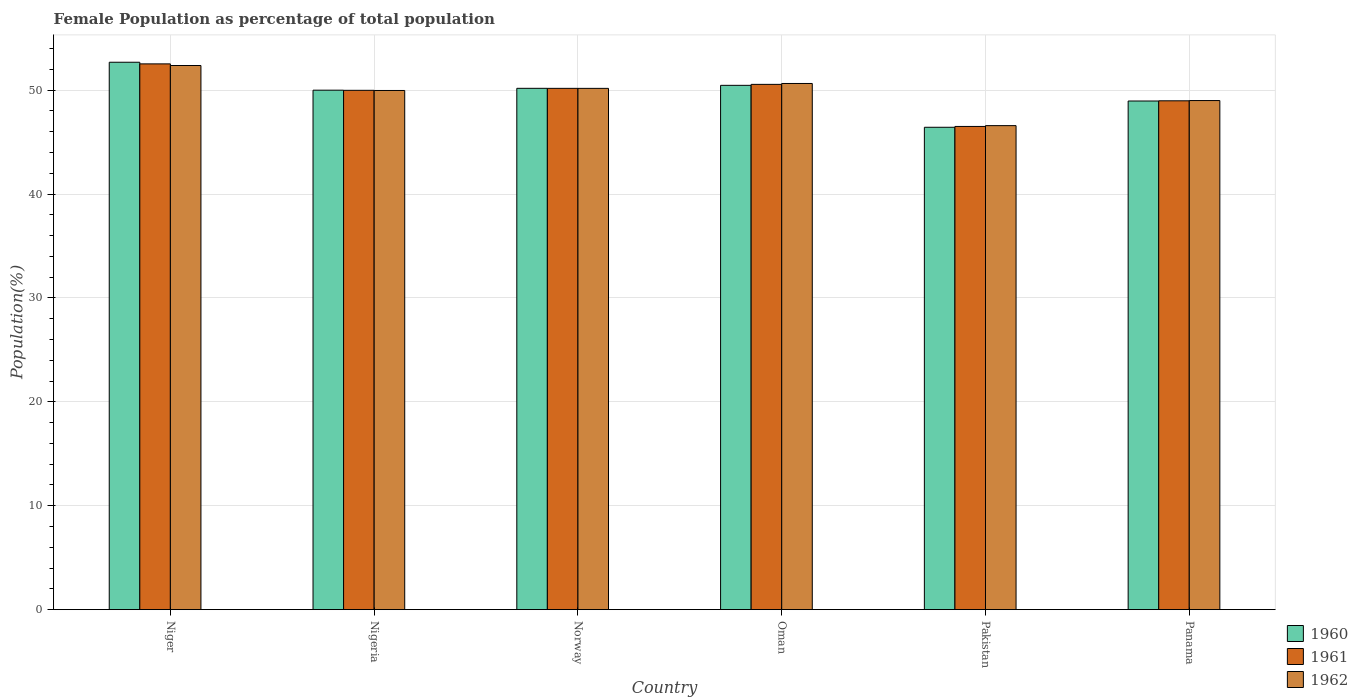Are the number of bars per tick equal to the number of legend labels?
Provide a short and direct response. Yes. Are the number of bars on each tick of the X-axis equal?
Your response must be concise. Yes. How many bars are there on the 5th tick from the left?
Ensure brevity in your answer.  3. What is the label of the 2nd group of bars from the left?
Keep it short and to the point. Nigeria. What is the female population in in 1962 in Oman?
Provide a short and direct response. 50.65. Across all countries, what is the maximum female population in in 1961?
Keep it short and to the point. 52.54. Across all countries, what is the minimum female population in in 1961?
Ensure brevity in your answer.  46.51. In which country was the female population in in 1962 maximum?
Offer a very short reply. Niger. What is the total female population in in 1962 in the graph?
Your answer should be compact. 298.77. What is the difference between the female population in in 1962 in Oman and that in Pakistan?
Your response must be concise. 4.06. What is the difference between the female population in in 1962 in Norway and the female population in in 1960 in Nigeria?
Your answer should be compact. 0.17. What is the average female population in in 1962 per country?
Offer a terse response. 49.8. What is the difference between the female population in of/in 1960 and female population in of/in 1962 in Oman?
Make the answer very short. -0.18. What is the ratio of the female population in in 1962 in Niger to that in Norway?
Your response must be concise. 1.04. What is the difference between the highest and the second highest female population in in 1962?
Provide a short and direct response. -1.73. What is the difference between the highest and the lowest female population in in 1960?
Give a very brief answer. 6.26. Is it the case that in every country, the sum of the female population in in 1962 and female population in in 1961 is greater than the female population in in 1960?
Make the answer very short. Yes. How many bars are there?
Give a very brief answer. 18. What is the difference between two consecutive major ticks on the Y-axis?
Offer a terse response. 10. Does the graph contain any zero values?
Provide a succinct answer. No. Does the graph contain grids?
Offer a terse response. Yes. Where does the legend appear in the graph?
Provide a short and direct response. Bottom right. What is the title of the graph?
Ensure brevity in your answer.  Female Population as percentage of total population. Does "1998" appear as one of the legend labels in the graph?
Offer a terse response. No. What is the label or title of the X-axis?
Offer a terse response. Country. What is the label or title of the Y-axis?
Your answer should be very brief. Population(%). What is the Population(%) of 1960 in Niger?
Keep it short and to the point. 52.69. What is the Population(%) in 1961 in Niger?
Give a very brief answer. 52.54. What is the Population(%) in 1962 in Niger?
Your response must be concise. 52.38. What is the Population(%) in 1960 in Nigeria?
Provide a succinct answer. 50. What is the Population(%) in 1961 in Nigeria?
Ensure brevity in your answer.  49.99. What is the Population(%) in 1962 in Nigeria?
Make the answer very short. 49.98. What is the Population(%) of 1960 in Norway?
Offer a terse response. 50.18. What is the Population(%) of 1961 in Norway?
Offer a very short reply. 50.18. What is the Population(%) in 1962 in Norway?
Give a very brief answer. 50.18. What is the Population(%) of 1960 in Oman?
Your response must be concise. 50.47. What is the Population(%) of 1961 in Oman?
Provide a succinct answer. 50.56. What is the Population(%) in 1962 in Oman?
Provide a short and direct response. 50.65. What is the Population(%) in 1960 in Pakistan?
Your answer should be very brief. 46.43. What is the Population(%) of 1961 in Pakistan?
Offer a very short reply. 46.51. What is the Population(%) of 1962 in Pakistan?
Your response must be concise. 46.59. What is the Population(%) in 1960 in Panama?
Your answer should be compact. 48.96. What is the Population(%) in 1961 in Panama?
Give a very brief answer. 48.98. What is the Population(%) of 1962 in Panama?
Make the answer very short. 49. Across all countries, what is the maximum Population(%) of 1960?
Provide a succinct answer. 52.69. Across all countries, what is the maximum Population(%) in 1961?
Ensure brevity in your answer.  52.54. Across all countries, what is the maximum Population(%) in 1962?
Give a very brief answer. 52.38. Across all countries, what is the minimum Population(%) in 1960?
Provide a short and direct response. 46.43. Across all countries, what is the minimum Population(%) in 1961?
Make the answer very short. 46.51. Across all countries, what is the minimum Population(%) in 1962?
Offer a terse response. 46.59. What is the total Population(%) in 1960 in the graph?
Your answer should be very brief. 298.74. What is the total Population(%) of 1961 in the graph?
Your answer should be very brief. 298.76. What is the total Population(%) in 1962 in the graph?
Ensure brevity in your answer.  298.77. What is the difference between the Population(%) in 1960 in Niger and that in Nigeria?
Make the answer very short. 2.69. What is the difference between the Population(%) of 1961 in Niger and that in Nigeria?
Provide a succinct answer. 2.55. What is the difference between the Population(%) of 1962 in Niger and that in Nigeria?
Your response must be concise. 2.4. What is the difference between the Population(%) in 1960 in Niger and that in Norway?
Ensure brevity in your answer.  2.51. What is the difference between the Population(%) in 1961 in Niger and that in Norway?
Make the answer very short. 2.36. What is the difference between the Population(%) of 1962 in Niger and that in Norway?
Give a very brief answer. 2.2. What is the difference between the Population(%) in 1960 in Niger and that in Oman?
Your response must be concise. 2.22. What is the difference between the Population(%) in 1961 in Niger and that in Oman?
Ensure brevity in your answer.  1.97. What is the difference between the Population(%) of 1962 in Niger and that in Oman?
Your response must be concise. 1.73. What is the difference between the Population(%) in 1960 in Niger and that in Pakistan?
Offer a terse response. 6.26. What is the difference between the Population(%) in 1961 in Niger and that in Pakistan?
Your answer should be very brief. 6.02. What is the difference between the Population(%) of 1962 in Niger and that in Pakistan?
Give a very brief answer. 5.79. What is the difference between the Population(%) of 1960 in Niger and that in Panama?
Offer a very short reply. 3.73. What is the difference between the Population(%) of 1961 in Niger and that in Panama?
Offer a terse response. 3.55. What is the difference between the Population(%) of 1962 in Niger and that in Panama?
Keep it short and to the point. 3.37. What is the difference between the Population(%) of 1960 in Nigeria and that in Norway?
Your answer should be compact. -0.18. What is the difference between the Population(%) in 1961 in Nigeria and that in Norway?
Your response must be concise. -0.19. What is the difference between the Population(%) of 1962 in Nigeria and that in Norway?
Provide a short and direct response. -0.2. What is the difference between the Population(%) of 1960 in Nigeria and that in Oman?
Provide a succinct answer. -0.47. What is the difference between the Population(%) of 1961 in Nigeria and that in Oman?
Provide a succinct answer. -0.57. What is the difference between the Population(%) in 1962 in Nigeria and that in Oman?
Make the answer very short. -0.67. What is the difference between the Population(%) of 1960 in Nigeria and that in Pakistan?
Your answer should be very brief. 3.57. What is the difference between the Population(%) in 1961 in Nigeria and that in Pakistan?
Provide a succinct answer. 3.48. What is the difference between the Population(%) in 1962 in Nigeria and that in Pakistan?
Provide a succinct answer. 3.38. What is the difference between the Population(%) of 1960 in Nigeria and that in Panama?
Your answer should be compact. 1.04. What is the difference between the Population(%) in 1961 in Nigeria and that in Panama?
Ensure brevity in your answer.  1.01. What is the difference between the Population(%) of 1962 in Nigeria and that in Panama?
Your answer should be compact. 0.97. What is the difference between the Population(%) of 1960 in Norway and that in Oman?
Provide a short and direct response. -0.29. What is the difference between the Population(%) of 1961 in Norway and that in Oman?
Your answer should be very brief. -0.38. What is the difference between the Population(%) of 1962 in Norway and that in Oman?
Your answer should be very brief. -0.47. What is the difference between the Population(%) in 1960 in Norway and that in Pakistan?
Your answer should be very brief. 3.75. What is the difference between the Population(%) in 1961 in Norway and that in Pakistan?
Your response must be concise. 3.67. What is the difference between the Population(%) of 1962 in Norway and that in Pakistan?
Offer a very short reply. 3.59. What is the difference between the Population(%) in 1960 in Norway and that in Panama?
Make the answer very short. 1.22. What is the difference between the Population(%) of 1961 in Norway and that in Panama?
Provide a succinct answer. 1.2. What is the difference between the Population(%) of 1962 in Norway and that in Panama?
Your answer should be very brief. 1.17. What is the difference between the Population(%) in 1960 in Oman and that in Pakistan?
Offer a very short reply. 4.04. What is the difference between the Population(%) of 1961 in Oman and that in Pakistan?
Provide a short and direct response. 4.05. What is the difference between the Population(%) in 1962 in Oman and that in Pakistan?
Your answer should be compact. 4.06. What is the difference between the Population(%) of 1960 in Oman and that in Panama?
Your response must be concise. 1.51. What is the difference between the Population(%) in 1961 in Oman and that in Panama?
Your response must be concise. 1.58. What is the difference between the Population(%) in 1962 in Oman and that in Panama?
Your response must be concise. 1.64. What is the difference between the Population(%) in 1960 in Pakistan and that in Panama?
Your answer should be very brief. -2.53. What is the difference between the Population(%) of 1961 in Pakistan and that in Panama?
Offer a very short reply. -2.47. What is the difference between the Population(%) in 1962 in Pakistan and that in Panama?
Offer a very short reply. -2.41. What is the difference between the Population(%) in 1960 in Niger and the Population(%) in 1961 in Nigeria?
Keep it short and to the point. 2.7. What is the difference between the Population(%) in 1960 in Niger and the Population(%) in 1962 in Nigeria?
Provide a succinct answer. 2.72. What is the difference between the Population(%) in 1961 in Niger and the Population(%) in 1962 in Nigeria?
Make the answer very short. 2.56. What is the difference between the Population(%) in 1960 in Niger and the Population(%) in 1961 in Norway?
Keep it short and to the point. 2.51. What is the difference between the Population(%) in 1960 in Niger and the Population(%) in 1962 in Norway?
Keep it short and to the point. 2.52. What is the difference between the Population(%) in 1961 in Niger and the Population(%) in 1962 in Norway?
Your response must be concise. 2.36. What is the difference between the Population(%) in 1960 in Niger and the Population(%) in 1961 in Oman?
Offer a terse response. 2.13. What is the difference between the Population(%) of 1960 in Niger and the Population(%) of 1962 in Oman?
Give a very brief answer. 2.04. What is the difference between the Population(%) of 1961 in Niger and the Population(%) of 1962 in Oman?
Provide a short and direct response. 1.89. What is the difference between the Population(%) of 1960 in Niger and the Population(%) of 1961 in Pakistan?
Provide a succinct answer. 6.18. What is the difference between the Population(%) of 1960 in Niger and the Population(%) of 1962 in Pakistan?
Provide a succinct answer. 6.1. What is the difference between the Population(%) of 1961 in Niger and the Population(%) of 1962 in Pakistan?
Your response must be concise. 5.95. What is the difference between the Population(%) of 1960 in Niger and the Population(%) of 1961 in Panama?
Provide a short and direct response. 3.71. What is the difference between the Population(%) in 1960 in Niger and the Population(%) in 1962 in Panama?
Ensure brevity in your answer.  3.69. What is the difference between the Population(%) of 1961 in Niger and the Population(%) of 1962 in Panama?
Your answer should be very brief. 3.53. What is the difference between the Population(%) in 1960 in Nigeria and the Population(%) in 1961 in Norway?
Provide a succinct answer. -0.18. What is the difference between the Population(%) in 1960 in Nigeria and the Population(%) in 1962 in Norway?
Your response must be concise. -0.17. What is the difference between the Population(%) in 1961 in Nigeria and the Population(%) in 1962 in Norway?
Provide a short and direct response. -0.19. What is the difference between the Population(%) of 1960 in Nigeria and the Population(%) of 1961 in Oman?
Give a very brief answer. -0.56. What is the difference between the Population(%) in 1960 in Nigeria and the Population(%) in 1962 in Oman?
Offer a very short reply. -0.64. What is the difference between the Population(%) of 1961 in Nigeria and the Population(%) of 1962 in Oman?
Provide a succinct answer. -0.66. What is the difference between the Population(%) of 1960 in Nigeria and the Population(%) of 1961 in Pakistan?
Your answer should be compact. 3.49. What is the difference between the Population(%) of 1960 in Nigeria and the Population(%) of 1962 in Pakistan?
Provide a short and direct response. 3.41. What is the difference between the Population(%) of 1961 in Nigeria and the Population(%) of 1962 in Pakistan?
Give a very brief answer. 3.4. What is the difference between the Population(%) in 1960 in Nigeria and the Population(%) in 1961 in Panama?
Ensure brevity in your answer.  1.02. What is the difference between the Population(%) of 1961 in Nigeria and the Population(%) of 1962 in Panama?
Give a very brief answer. 0.99. What is the difference between the Population(%) of 1960 in Norway and the Population(%) of 1961 in Oman?
Provide a succinct answer. -0.38. What is the difference between the Population(%) in 1960 in Norway and the Population(%) in 1962 in Oman?
Provide a short and direct response. -0.47. What is the difference between the Population(%) of 1961 in Norway and the Population(%) of 1962 in Oman?
Make the answer very short. -0.47. What is the difference between the Population(%) in 1960 in Norway and the Population(%) in 1961 in Pakistan?
Your answer should be very brief. 3.67. What is the difference between the Population(%) in 1960 in Norway and the Population(%) in 1962 in Pakistan?
Offer a terse response. 3.59. What is the difference between the Population(%) in 1961 in Norway and the Population(%) in 1962 in Pakistan?
Your response must be concise. 3.59. What is the difference between the Population(%) in 1960 in Norway and the Population(%) in 1961 in Panama?
Make the answer very short. 1.2. What is the difference between the Population(%) in 1960 in Norway and the Population(%) in 1962 in Panama?
Provide a short and direct response. 1.18. What is the difference between the Population(%) of 1961 in Norway and the Population(%) of 1962 in Panama?
Provide a succinct answer. 1.17. What is the difference between the Population(%) in 1960 in Oman and the Population(%) in 1961 in Pakistan?
Your answer should be compact. 3.96. What is the difference between the Population(%) in 1960 in Oman and the Population(%) in 1962 in Pakistan?
Provide a short and direct response. 3.88. What is the difference between the Population(%) in 1961 in Oman and the Population(%) in 1962 in Pakistan?
Provide a succinct answer. 3.97. What is the difference between the Population(%) in 1960 in Oman and the Population(%) in 1961 in Panama?
Offer a terse response. 1.49. What is the difference between the Population(%) of 1960 in Oman and the Population(%) of 1962 in Panama?
Offer a very short reply. 1.46. What is the difference between the Population(%) of 1961 in Oman and the Population(%) of 1962 in Panama?
Keep it short and to the point. 1.56. What is the difference between the Population(%) of 1960 in Pakistan and the Population(%) of 1961 in Panama?
Your answer should be very brief. -2.55. What is the difference between the Population(%) of 1960 in Pakistan and the Population(%) of 1962 in Panama?
Keep it short and to the point. -2.57. What is the difference between the Population(%) of 1961 in Pakistan and the Population(%) of 1962 in Panama?
Give a very brief answer. -2.49. What is the average Population(%) in 1960 per country?
Provide a succinct answer. 49.79. What is the average Population(%) in 1961 per country?
Offer a very short reply. 49.79. What is the average Population(%) of 1962 per country?
Keep it short and to the point. 49.8. What is the difference between the Population(%) in 1960 and Population(%) in 1961 in Niger?
Your answer should be compact. 0.16. What is the difference between the Population(%) of 1960 and Population(%) of 1962 in Niger?
Offer a terse response. 0.31. What is the difference between the Population(%) in 1961 and Population(%) in 1962 in Niger?
Offer a terse response. 0.16. What is the difference between the Population(%) of 1960 and Population(%) of 1961 in Nigeria?
Your answer should be compact. 0.01. What is the difference between the Population(%) of 1960 and Population(%) of 1962 in Nigeria?
Your answer should be very brief. 0.03. What is the difference between the Population(%) in 1961 and Population(%) in 1962 in Nigeria?
Your response must be concise. 0.01. What is the difference between the Population(%) of 1960 and Population(%) of 1961 in Norway?
Make the answer very short. 0. What is the difference between the Population(%) in 1960 and Population(%) in 1962 in Norway?
Keep it short and to the point. 0.01. What is the difference between the Population(%) in 1961 and Population(%) in 1962 in Norway?
Your answer should be compact. 0. What is the difference between the Population(%) in 1960 and Population(%) in 1961 in Oman?
Ensure brevity in your answer.  -0.09. What is the difference between the Population(%) of 1960 and Population(%) of 1962 in Oman?
Provide a succinct answer. -0.18. What is the difference between the Population(%) in 1961 and Population(%) in 1962 in Oman?
Ensure brevity in your answer.  -0.08. What is the difference between the Population(%) in 1960 and Population(%) in 1961 in Pakistan?
Your answer should be compact. -0.08. What is the difference between the Population(%) of 1960 and Population(%) of 1962 in Pakistan?
Your answer should be compact. -0.16. What is the difference between the Population(%) in 1961 and Population(%) in 1962 in Pakistan?
Your response must be concise. -0.08. What is the difference between the Population(%) of 1960 and Population(%) of 1961 in Panama?
Give a very brief answer. -0.02. What is the difference between the Population(%) of 1960 and Population(%) of 1962 in Panama?
Your answer should be very brief. -0.04. What is the difference between the Population(%) in 1961 and Population(%) in 1962 in Panama?
Your response must be concise. -0.02. What is the ratio of the Population(%) of 1960 in Niger to that in Nigeria?
Make the answer very short. 1.05. What is the ratio of the Population(%) of 1961 in Niger to that in Nigeria?
Keep it short and to the point. 1.05. What is the ratio of the Population(%) in 1962 in Niger to that in Nigeria?
Provide a short and direct response. 1.05. What is the ratio of the Population(%) in 1961 in Niger to that in Norway?
Provide a short and direct response. 1.05. What is the ratio of the Population(%) in 1962 in Niger to that in Norway?
Keep it short and to the point. 1.04. What is the ratio of the Population(%) in 1960 in Niger to that in Oman?
Offer a very short reply. 1.04. What is the ratio of the Population(%) of 1961 in Niger to that in Oman?
Ensure brevity in your answer.  1.04. What is the ratio of the Population(%) in 1962 in Niger to that in Oman?
Your response must be concise. 1.03. What is the ratio of the Population(%) of 1960 in Niger to that in Pakistan?
Provide a short and direct response. 1.13. What is the ratio of the Population(%) of 1961 in Niger to that in Pakistan?
Keep it short and to the point. 1.13. What is the ratio of the Population(%) in 1962 in Niger to that in Pakistan?
Ensure brevity in your answer.  1.12. What is the ratio of the Population(%) in 1960 in Niger to that in Panama?
Give a very brief answer. 1.08. What is the ratio of the Population(%) of 1961 in Niger to that in Panama?
Your answer should be compact. 1.07. What is the ratio of the Population(%) in 1962 in Niger to that in Panama?
Provide a succinct answer. 1.07. What is the ratio of the Population(%) of 1961 in Nigeria to that in Oman?
Ensure brevity in your answer.  0.99. What is the ratio of the Population(%) of 1962 in Nigeria to that in Oman?
Offer a terse response. 0.99. What is the ratio of the Population(%) of 1961 in Nigeria to that in Pakistan?
Provide a succinct answer. 1.07. What is the ratio of the Population(%) in 1962 in Nigeria to that in Pakistan?
Give a very brief answer. 1.07. What is the ratio of the Population(%) in 1960 in Nigeria to that in Panama?
Give a very brief answer. 1.02. What is the ratio of the Population(%) in 1961 in Nigeria to that in Panama?
Offer a very short reply. 1.02. What is the ratio of the Population(%) of 1962 in Nigeria to that in Panama?
Your response must be concise. 1.02. What is the ratio of the Population(%) in 1960 in Norway to that in Oman?
Offer a terse response. 0.99. What is the ratio of the Population(%) in 1961 in Norway to that in Oman?
Make the answer very short. 0.99. What is the ratio of the Population(%) in 1962 in Norway to that in Oman?
Make the answer very short. 0.99. What is the ratio of the Population(%) of 1960 in Norway to that in Pakistan?
Make the answer very short. 1.08. What is the ratio of the Population(%) of 1961 in Norway to that in Pakistan?
Your response must be concise. 1.08. What is the ratio of the Population(%) of 1962 in Norway to that in Pakistan?
Your answer should be compact. 1.08. What is the ratio of the Population(%) of 1961 in Norway to that in Panama?
Ensure brevity in your answer.  1.02. What is the ratio of the Population(%) in 1962 in Norway to that in Panama?
Offer a terse response. 1.02. What is the ratio of the Population(%) of 1960 in Oman to that in Pakistan?
Provide a short and direct response. 1.09. What is the ratio of the Population(%) of 1961 in Oman to that in Pakistan?
Your response must be concise. 1.09. What is the ratio of the Population(%) in 1962 in Oman to that in Pakistan?
Keep it short and to the point. 1.09. What is the ratio of the Population(%) of 1960 in Oman to that in Panama?
Provide a short and direct response. 1.03. What is the ratio of the Population(%) of 1961 in Oman to that in Panama?
Offer a very short reply. 1.03. What is the ratio of the Population(%) in 1962 in Oman to that in Panama?
Provide a short and direct response. 1.03. What is the ratio of the Population(%) in 1960 in Pakistan to that in Panama?
Offer a terse response. 0.95. What is the ratio of the Population(%) of 1961 in Pakistan to that in Panama?
Keep it short and to the point. 0.95. What is the ratio of the Population(%) of 1962 in Pakistan to that in Panama?
Provide a succinct answer. 0.95. What is the difference between the highest and the second highest Population(%) of 1960?
Give a very brief answer. 2.22. What is the difference between the highest and the second highest Population(%) of 1961?
Offer a very short reply. 1.97. What is the difference between the highest and the second highest Population(%) of 1962?
Keep it short and to the point. 1.73. What is the difference between the highest and the lowest Population(%) in 1960?
Provide a short and direct response. 6.26. What is the difference between the highest and the lowest Population(%) of 1961?
Offer a very short reply. 6.02. What is the difference between the highest and the lowest Population(%) in 1962?
Your response must be concise. 5.79. 